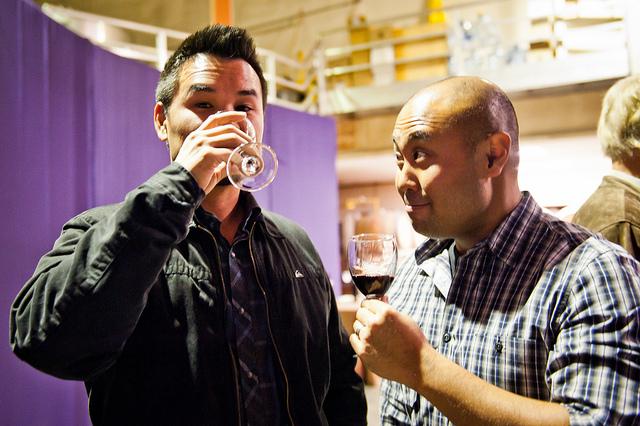Why are his eyes closed?
Answer briefly. Drinking. What kind of shirt is the man on the right wearing?
Quick response, please. Plaid. What are the people holding?
Be succinct. Wine glasses. Are the men drinking beer or wine?
Quick response, please. Wine. 